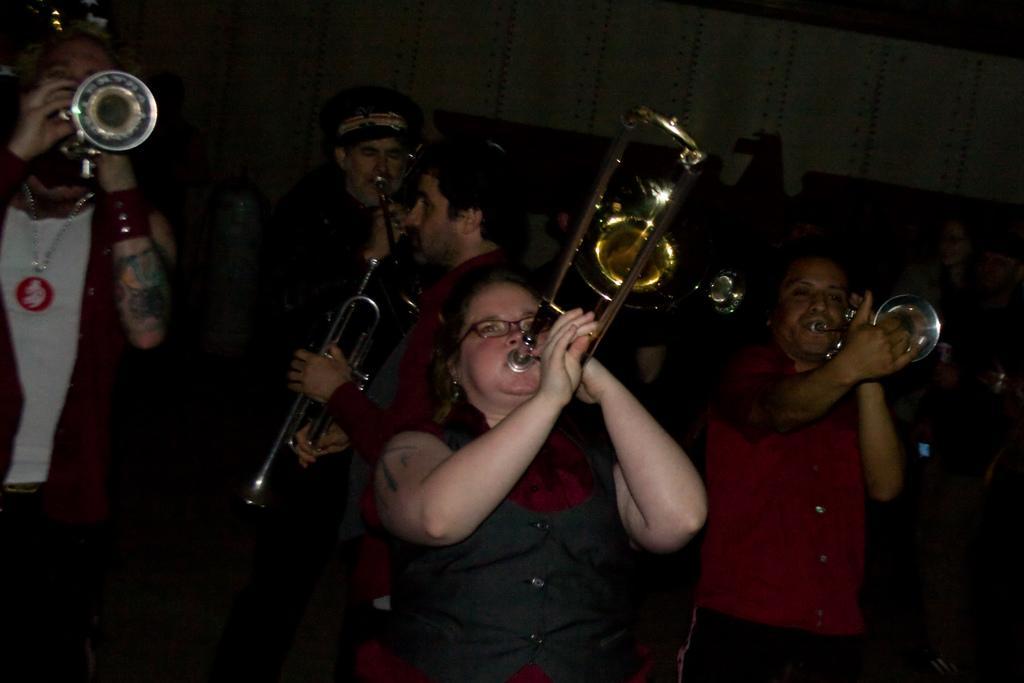Please provide a concise description of this image. In the image there are many people playing trumpet and in the back there is wall. 